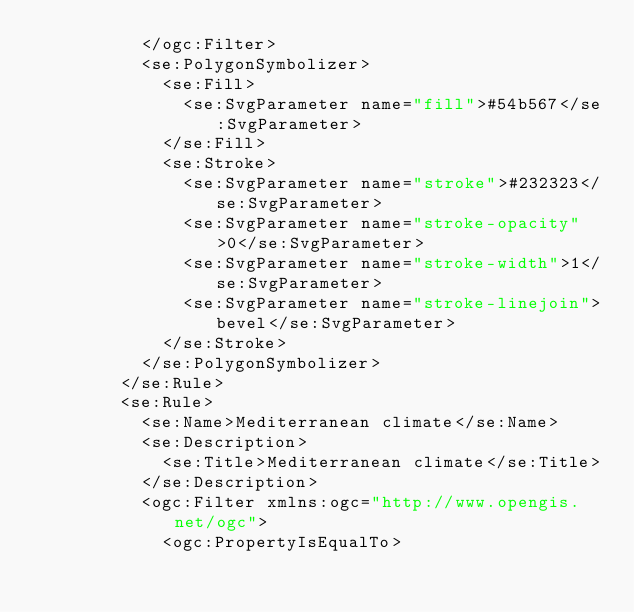<code> <loc_0><loc_0><loc_500><loc_500><_Scheme_>          </ogc:Filter>
          <se:PolygonSymbolizer>
            <se:Fill>
              <se:SvgParameter name="fill">#54b567</se:SvgParameter>
            </se:Fill>
            <se:Stroke>
              <se:SvgParameter name="stroke">#232323</se:SvgParameter>
              <se:SvgParameter name="stroke-opacity">0</se:SvgParameter>
              <se:SvgParameter name="stroke-width">1</se:SvgParameter>
              <se:SvgParameter name="stroke-linejoin">bevel</se:SvgParameter>
            </se:Stroke>
          </se:PolygonSymbolizer>
        </se:Rule>
        <se:Rule>
          <se:Name>Mediterranean climate</se:Name>
          <se:Description>
            <se:Title>Mediterranean climate</se:Title>
          </se:Description>
          <ogc:Filter xmlns:ogc="http://www.opengis.net/ogc">
            <ogc:PropertyIsEqualTo></code> 